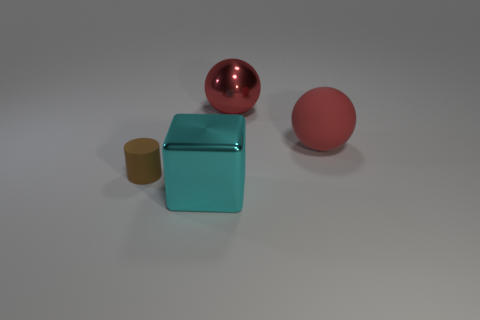Is the number of small brown things greater than the number of metallic objects? no 